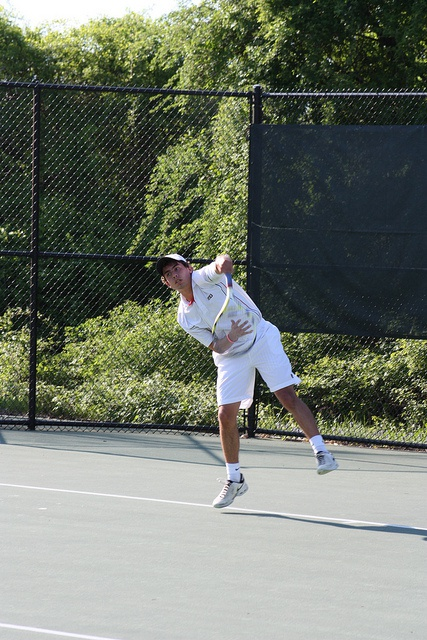Describe the objects in this image and their specific colors. I can see people in white, darkgray, gray, and lavender tones and tennis racket in white, darkgray, and gray tones in this image. 